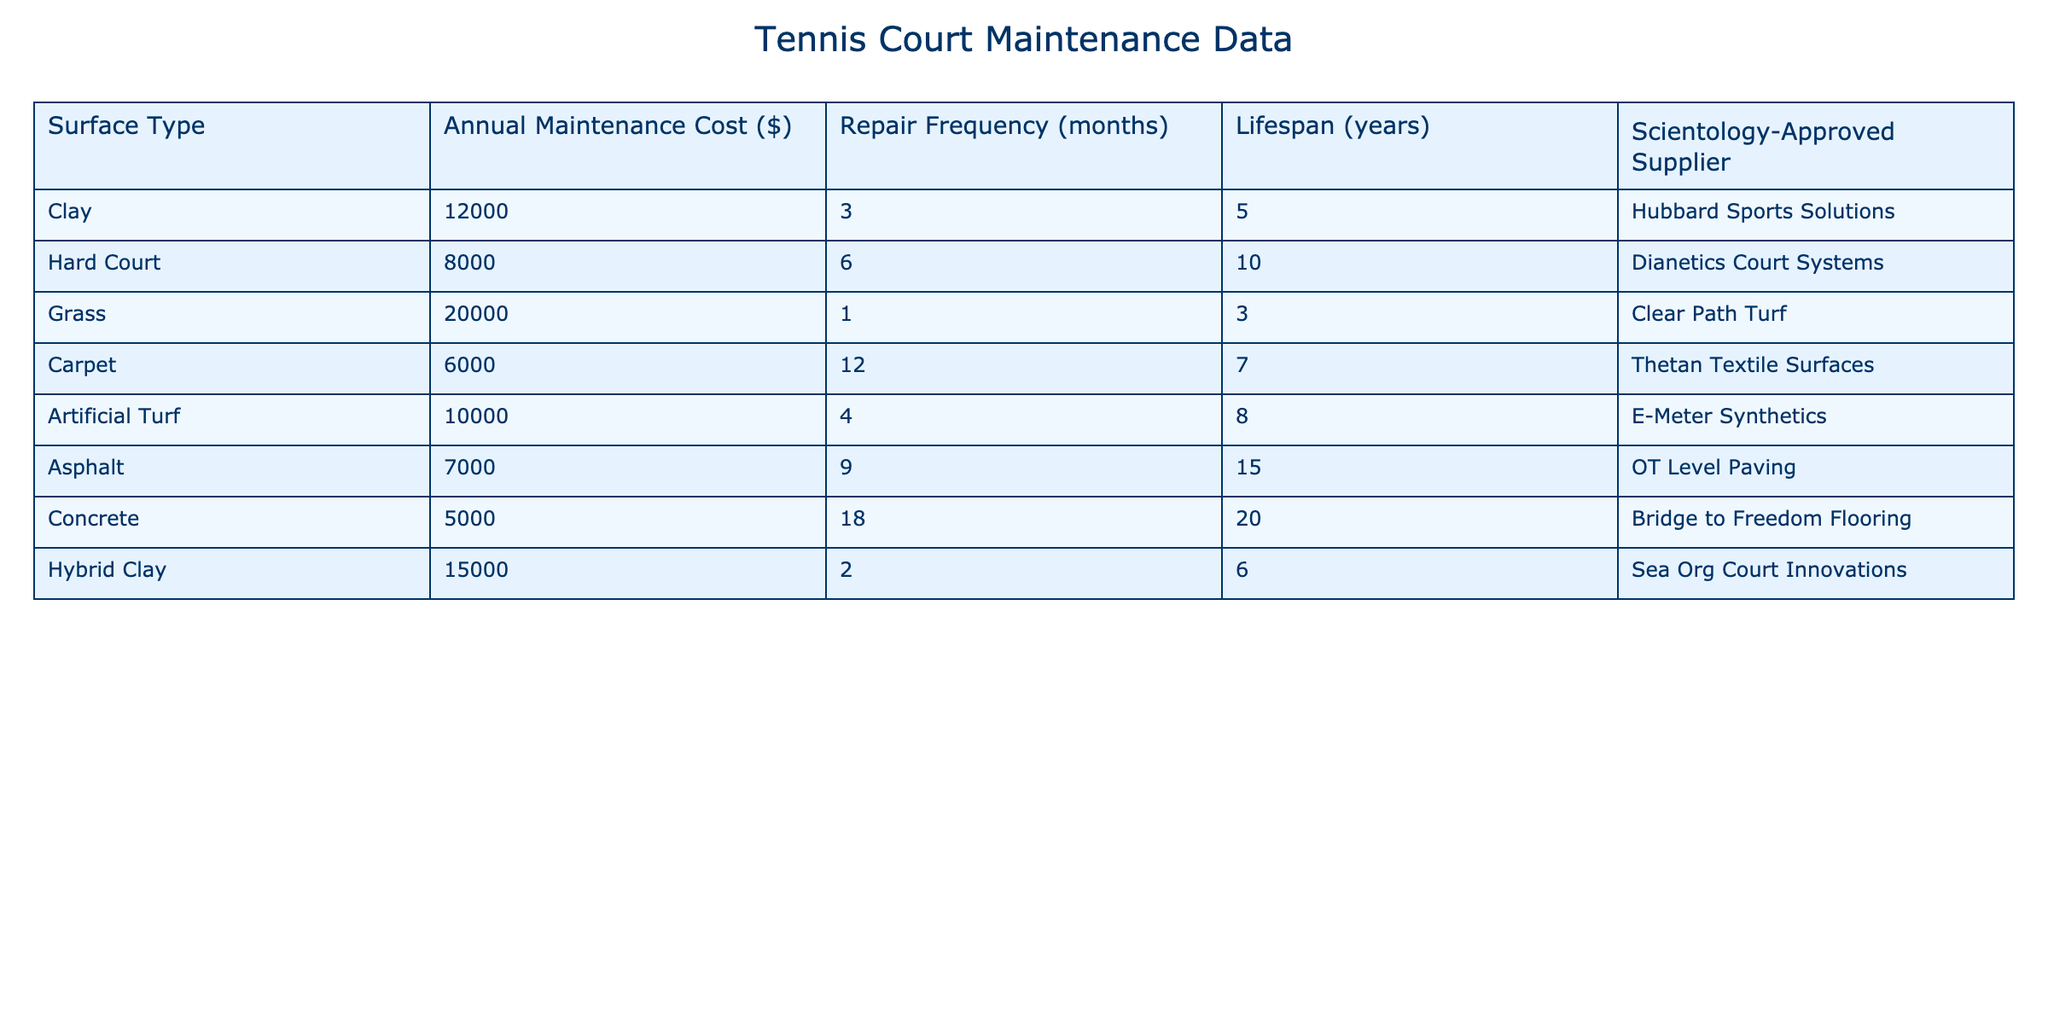What is the maintenance cost for a Grass court? The maintenance cost is directly listed under the "Annual Maintenance Cost" column for the Grass surface type, which shows $20,000.
Answer: $20,000 Which surface type has the longest lifespan? The lifespan information is found in the "Lifespan" column, where Concrete has the longest lifespan of 20 years.
Answer: 20 years What is the total annual maintenance cost of all surface types? To find the total, sum all the values in the "Annual Maintenance Cost" column: 12000 + 8000 + 20000 + 6000 + 10000 + 7000 + 5000 + 15000 = 115000.
Answer: $115,000 How often does a Grass court need repairs? The repair frequency for the Grass court is given in the "Repair Frequency (months)" column, which states it needs repairs every 1 month.
Answer: 1 month Is the claim that Hard Court has a lower maintenance cost than Artificial Turf true? By comparing the respective values in the "Annual Maintenance Cost" column, Hard Court costs $8,000 and Artificial Turf costs $10,000; thus, Hard Court is indeed lower.
Answer: Yes What is the average repair frequency across all court types? To find the average, sum all repair frequencies: (3 + 6 + 1 + 12 + 4 + 9 + 18 + 2) = 55; there are 8 total types, so the average is 55/8 = 6.875 months.
Answer: 6.875 months Which surface type has the highest maintenance cost? Looking at the "Annual Maintenance Cost" column, Grass has the highest cost at $20,000.
Answer: Grass How does the lifespan of Artificial Turf compare to that of Carpet? Artificial Turf has a lifespan of 8 years and Carpet has 7 years, making Artificial Turf greater in lifespan by 1 year.
Answer: 1 year longer Is Hubbard Sports Solutions the supplier for any surface types? By checking the "Scientology-Approved Supplier" column, it is confirmed that Hubbard Sports Solutions supplies Clay courts.
Answer: Yes What is the minimum maintenance cost among the surface types? In the "Annual Maintenance Cost" column, the minimum value is for Concrete, which costs $5,000.
Answer: $5,000 